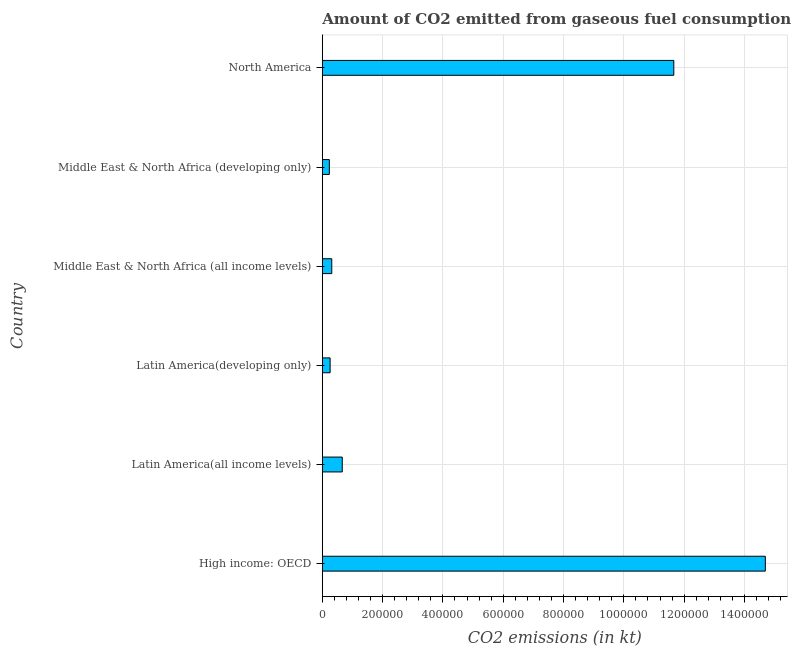Does the graph contain any zero values?
Offer a terse response. No. What is the title of the graph?
Your answer should be very brief. Amount of CO2 emitted from gaseous fuel consumption by different countries in 1971. What is the label or title of the X-axis?
Provide a short and direct response. CO2 emissions (in kt). What is the co2 emissions from gaseous fuel consumption in Latin America(all income levels)?
Provide a short and direct response. 6.61e+04. Across all countries, what is the maximum co2 emissions from gaseous fuel consumption?
Ensure brevity in your answer.  1.47e+06. Across all countries, what is the minimum co2 emissions from gaseous fuel consumption?
Your answer should be very brief. 2.32e+04. In which country was the co2 emissions from gaseous fuel consumption maximum?
Provide a short and direct response. High income: OECD. In which country was the co2 emissions from gaseous fuel consumption minimum?
Provide a short and direct response. Middle East & North Africa (developing only). What is the sum of the co2 emissions from gaseous fuel consumption?
Your answer should be very brief. 2.78e+06. What is the difference between the co2 emissions from gaseous fuel consumption in Latin America(developing only) and North America?
Your answer should be compact. -1.14e+06. What is the average co2 emissions from gaseous fuel consumption per country?
Offer a very short reply. 4.64e+05. What is the median co2 emissions from gaseous fuel consumption?
Offer a very short reply. 4.87e+04. In how many countries, is the co2 emissions from gaseous fuel consumption greater than 1480000 kt?
Your answer should be very brief. 0. What is the ratio of the co2 emissions from gaseous fuel consumption in Latin America(developing only) to that in Middle East & North Africa (developing only)?
Ensure brevity in your answer.  1.11. Is the co2 emissions from gaseous fuel consumption in Middle East & North Africa (all income levels) less than that in North America?
Your answer should be compact. Yes. What is the difference between the highest and the second highest co2 emissions from gaseous fuel consumption?
Give a very brief answer. 3.04e+05. Is the sum of the co2 emissions from gaseous fuel consumption in Latin America(all income levels) and North America greater than the maximum co2 emissions from gaseous fuel consumption across all countries?
Keep it short and to the point. No. What is the difference between the highest and the lowest co2 emissions from gaseous fuel consumption?
Make the answer very short. 1.45e+06. How many bars are there?
Your response must be concise. 6. How many countries are there in the graph?
Keep it short and to the point. 6. Are the values on the major ticks of X-axis written in scientific E-notation?
Provide a succinct answer. No. What is the CO2 emissions (in kt) in High income: OECD?
Offer a very short reply. 1.47e+06. What is the CO2 emissions (in kt) of Latin America(all income levels)?
Your answer should be compact. 6.61e+04. What is the CO2 emissions (in kt) in Latin America(developing only)?
Ensure brevity in your answer.  2.59e+04. What is the CO2 emissions (in kt) in Middle East & North Africa (all income levels)?
Your answer should be compact. 3.13e+04. What is the CO2 emissions (in kt) of Middle East & North Africa (developing only)?
Give a very brief answer. 2.32e+04. What is the CO2 emissions (in kt) of North America?
Your answer should be very brief. 1.17e+06. What is the difference between the CO2 emissions (in kt) in High income: OECD and Latin America(all income levels)?
Your answer should be compact. 1.40e+06. What is the difference between the CO2 emissions (in kt) in High income: OECD and Latin America(developing only)?
Your response must be concise. 1.44e+06. What is the difference between the CO2 emissions (in kt) in High income: OECD and Middle East & North Africa (all income levels)?
Provide a short and direct response. 1.44e+06. What is the difference between the CO2 emissions (in kt) in High income: OECD and Middle East & North Africa (developing only)?
Make the answer very short. 1.45e+06. What is the difference between the CO2 emissions (in kt) in High income: OECD and North America?
Keep it short and to the point. 3.04e+05. What is the difference between the CO2 emissions (in kt) in Latin America(all income levels) and Latin America(developing only)?
Ensure brevity in your answer.  4.02e+04. What is the difference between the CO2 emissions (in kt) in Latin America(all income levels) and Middle East & North Africa (all income levels)?
Keep it short and to the point. 3.48e+04. What is the difference between the CO2 emissions (in kt) in Latin America(all income levels) and Middle East & North Africa (developing only)?
Offer a terse response. 4.29e+04. What is the difference between the CO2 emissions (in kt) in Latin America(all income levels) and North America?
Your answer should be very brief. -1.10e+06. What is the difference between the CO2 emissions (in kt) in Latin America(developing only) and Middle East & North Africa (all income levels)?
Keep it short and to the point. -5428.67. What is the difference between the CO2 emissions (in kt) in Latin America(developing only) and Middle East & North Africa (developing only)?
Provide a short and direct response. 2630.18. What is the difference between the CO2 emissions (in kt) in Latin America(developing only) and North America?
Make the answer very short. -1.14e+06. What is the difference between the CO2 emissions (in kt) in Middle East & North Africa (all income levels) and Middle East & North Africa (developing only)?
Your answer should be very brief. 8058.84. What is the difference between the CO2 emissions (in kt) in Middle East & North Africa (all income levels) and North America?
Provide a succinct answer. -1.13e+06. What is the difference between the CO2 emissions (in kt) in Middle East & North Africa (developing only) and North America?
Provide a succinct answer. -1.14e+06. What is the ratio of the CO2 emissions (in kt) in High income: OECD to that in Latin America(all income levels)?
Provide a succinct answer. 22.23. What is the ratio of the CO2 emissions (in kt) in High income: OECD to that in Latin America(developing only)?
Your answer should be very brief. 56.83. What is the ratio of the CO2 emissions (in kt) in High income: OECD to that in Middle East & North Africa (all income levels)?
Make the answer very short. 46.97. What is the ratio of the CO2 emissions (in kt) in High income: OECD to that in Middle East & North Africa (developing only)?
Ensure brevity in your answer.  63.26. What is the ratio of the CO2 emissions (in kt) in High income: OECD to that in North America?
Provide a short and direct response. 1.26. What is the ratio of the CO2 emissions (in kt) in Latin America(all income levels) to that in Latin America(developing only)?
Provide a succinct answer. 2.56. What is the ratio of the CO2 emissions (in kt) in Latin America(all income levels) to that in Middle East & North Africa (all income levels)?
Give a very brief answer. 2.11. What is the ratio of the CO2 emissions (in kt) in Latin America(all income levels) to that in Middle East & North Africa (developing only)?
Your response must be concise. 2.85. What is the ratio of the CO2 emissions (in kt) in Latin America(all income levels) to that in North America?
Your response must be concise. 0.06. What is the ratio of the CO2 emissions (in kt) in Latin America(developing only) to that in Middle East & North Africa (all income levels)?
Your answer should be very brief. 0.83. What is the ratio of the CO2 emissions (in kt) in Latin America(developing only) to that in Middle East & North Africa (developing only)?
Keep it short and to the point. 1.11. What is the ratio of the CO2 emissions (in kt) in Latin America(developing only) to that in North America?
Provide a succinct answer. 0.02. What is the ratio of the CO2 emissions (in kt) in Middle East & North Africa (all income levels) to that in Middle East & North Africa (developing only)?
Offer a very short reply. 1.35. What is the ratio of the CO2 emissions (in kt) in Middle East & North Africa (all income levels) to that in North America?
Keep it short and to the point. 0.03. What is the ratio of the CO2 emissions (in kt) in Middle East & North Africa (developing only) to that in North America?
Give a very brief answer. 0.02. 